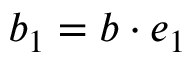<formula> <loc_0><loc_0><loc_500><loc_500>b _ { 1 } = b \cdot e _ { 1 }</formula> 